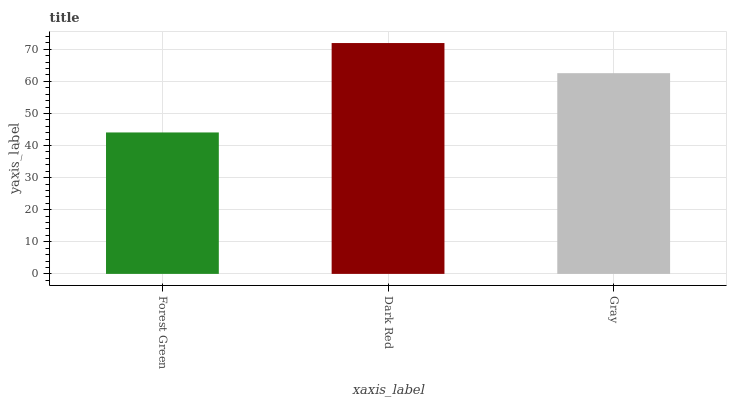Is Gray the minimum?
Answer yes or no. No. Is Gray the maximum?
Answer yes or no. No. Is Dark Red greater than Gray?
Answer yes or no. Yes. Is Gray less than Dark Red?
Answer yes or no. Yes. Is Gray greater than Dark Red?
Answer yes or no. No. Is Dark Red less than Gray?
Answer yes or no. No. Is Gray the high median?
Answer yes or no. Yes. Is Gray the low median?
Answer yes or no. Yes. Is Forest Green the high median?
Answer yes or no. No. Is Forest Green the low median?
Answer yes or no. No. 